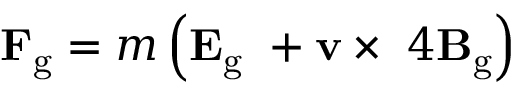Convert formula to latex. <formula><loc_0><loc_0><loc_500><loc_500>F _ { g } = m \left ( E _ { g } \ + v \times \ 4 B _ { g } \right )</formula> 